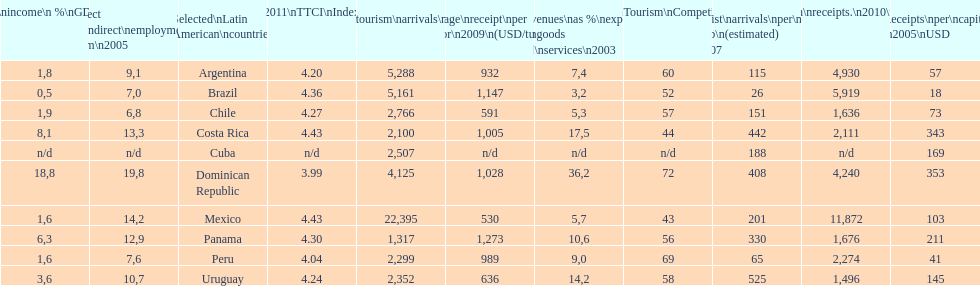Which latin american country had the largest number of tourism arrivals in 2010? Mexico. 